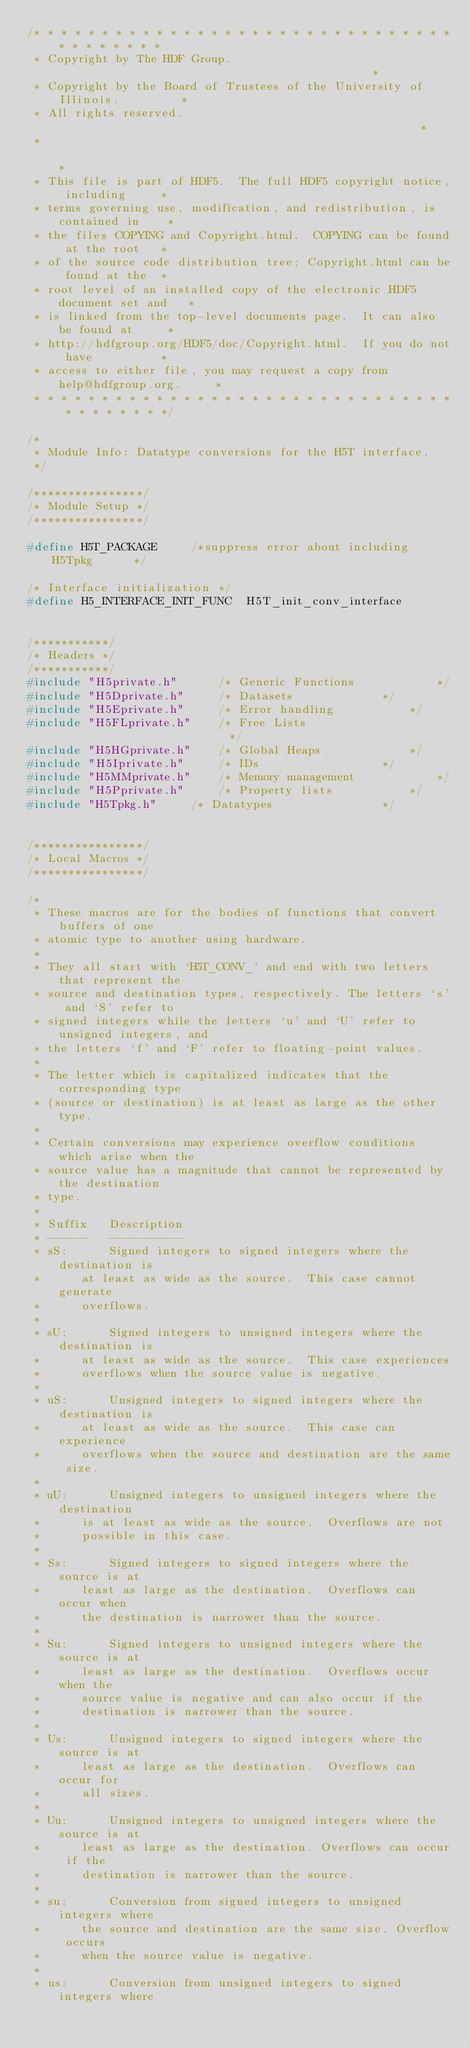Convert code to text. <code><loc_0><loc_0><loc_500><loc_500><_C_>/* * * * * * * * * * * * * * * * * * * * * * * * * * * * * * * * * * * * * * *
 * Copyright by The HDF Group.                                               *
 * Copyright by the Board of Trustees of the University of Illinois.         *
 * All rights reserved.                                                      *
 *                                                                           *
 * This file is part of HDF5.  The full HDF5 copyright notice, including     *
 * terms governing use, modification, and redistribution, is contained in    *
 * the files COPYING and Copyright.html.  COPYING can be found at the root   *
 * of the source code distribution tree; Copyright.html can be found at the  *
 * root level of an installed copy of the electronic HDF5 document set and   *
 * is linked from the top-level documents page.  It can also be found at     *
 * http://hdfgroup.org/HDF5/doc/Copyright.html.  If you do not have          *
 * access to either file, you may request a copy from help@hdfgroup.org.     *
 * * * * * * * * * * * * * * * * * * * * * * * * * * * * * * * * * * * * * * */

/*
 * Module Info:	Datatype conversions for the H5T interface.
 */

/****************/
/* Module Setup */
/****************/

#define H5T_PACKAGE		/*suppress error about including H5Tpkg	     */

/* Interface initialization */
#define H5_INTERFACE_INIT_FUNC	H5T_init_conv_interface


/***********/
/* Headers */
/***********/
#include "H5private.h"		/* Generic Functions			*/
#include "H5Dprivate.h"		/* Datasets				*/
#include "H5Eprivate.h"		/* Error handling		  	*/
#include "H5FLprivate.h"	/* Free Lists                           */
#include "H5HGprivate.h"	/* Global Heaps				*/
#include "H5Iprivate.h"		/* IDs			  		*/
#include "H5MMprivate.h"	/* Memory management			*/
#include "H5Pprivate.h"		/* Property lists			*/
#include "H5Tpkg.h"		/* Datatypes				*/


/****************/
/* Local Macros */
/****************/

/*
 * These macros are for the bodies of functions that convert buffers of one
 * atomic type to another using hardware.
 *
 * They all start with `H5T_CONV_' and end with two letters that represent the
 * source and destination types, respectively. The letters `s' and `S' refer to
 * signed integers while the letters `u' and `U' refer to unsigned integers, and
 * the letters `f' and `F' refer to floating-point values.
 *
 * The letter which is capitalized indicates that the corresponding type
 * (source or destination) is at least as large as the other type.
 *
 * Certain conversions may experience overflow conditions which arise when the
 * source value has a magnitude that cannot be represented by the destination
 * type.
 *
 * Suffix	Description
 * ------	-----------
 * sS:		Signed integers to signed integers where the destination is
 *		at least as wide as the source.	 This case cannot generate
 *		overflows.
 *
 * sU:		Signed integers to unsigned integers where the destination is
 *		at least as wide as the source.	 This case experiences
 *		overflows when the source value is negative.
 *
 * uS:		Unsigned integers to signed integers where the destination is
 *		at least as wide as the source.	 This case can experience
 *		overflows when the source and destination are the same size.
 *
 * uU:		Unsigned integers to unsigned integers where the destination
 *		is at least as wide as the source.  Overflows are not
 *		possible in this case.
 *
 * Ss:		Signed integers to signed integers where the source is at
 *		least as large as the destination.  Overflows can occur when
 *		the destination is narrower than the source.
 *
 * Su:		Signed integers to unsigned integers where the source is at
 *		least as large as the destination.  Overflows occur when the
 *		source value is negative and can also occur if the
 *		destination is narrower than the source.
 *
 * Us:		Unsigned integers to signed integers where the source is at
 *		least as large as the destination.  Overflows can occur for
 *		all sizes.
 *
 * Uu:		Unsigned integers to unsigned integers where the source is at
 *		least as large as the destination. Overflows can occur if the
 *		destination is narrower than the source.
 *
 * su:		Conversion from signed integers to unsigned integers where
 *		the source and destination are the same size. Overflow occurs
 *		when the source value is negative.
 *
 * us:		Conversion from unsigned integers to signed integers where</code> 